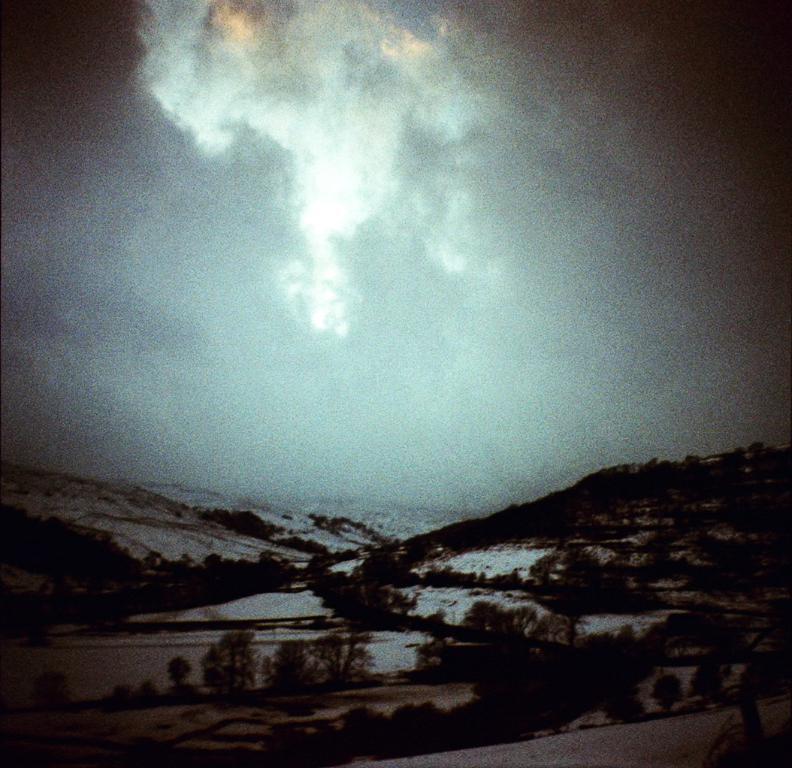How would you summarize this image in a sentence or two? In this image in front there is a road. There are plants. In the background of the image there is snow on the surface. There are mountains and sky. 